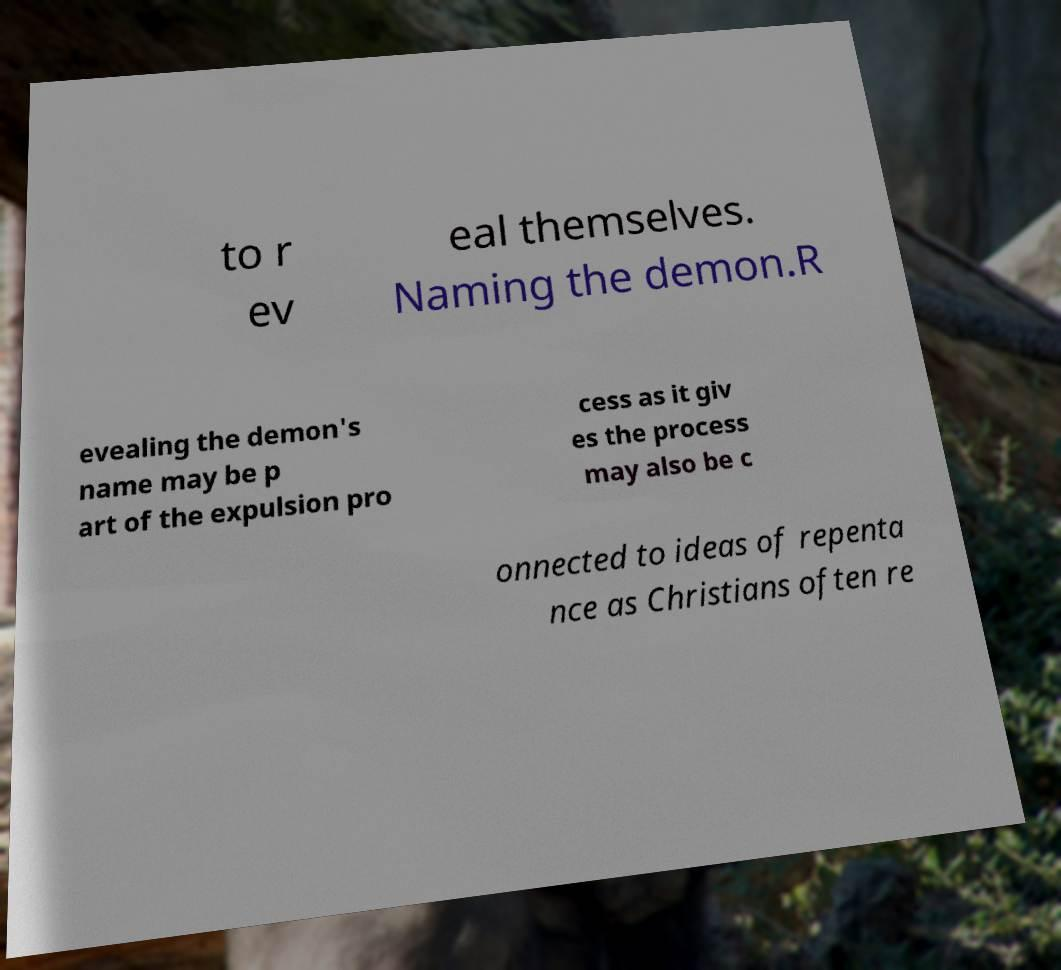Could you assist in decoding the text presented in this image and type it out clearly? to r ev eal themselves. Naming the demon.R evealing the demon's name may be p art of the expulsion pro cess as it giv es the process may also be c onnected to ideas of repenta nce as Christians often re 